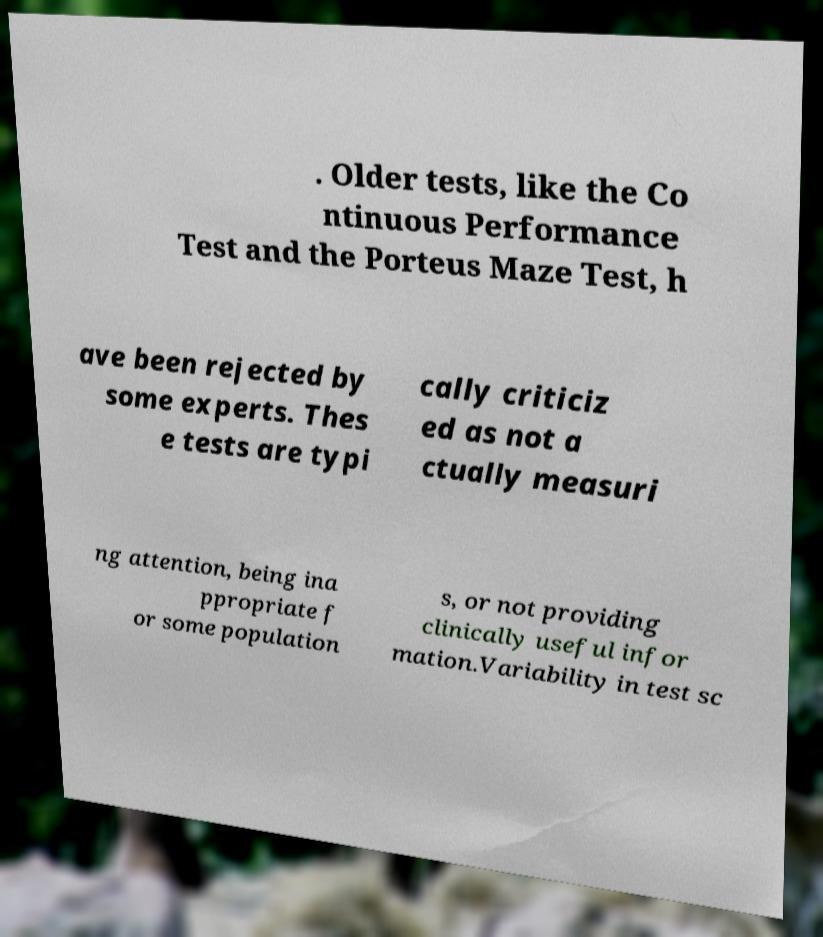What messages or text are displayed in this image? I need them in a readable, typed format. . Older tests, like the Co ntinuous Performance Test and the Porteus Maze Test, h ave been rejected by some experts. Thes e tests are typi cally criticiz ed as not a ctually measuri ng attention, being ina ppropriate f or some population s, or not providing clinically useful infor mation.Variability in test sc 